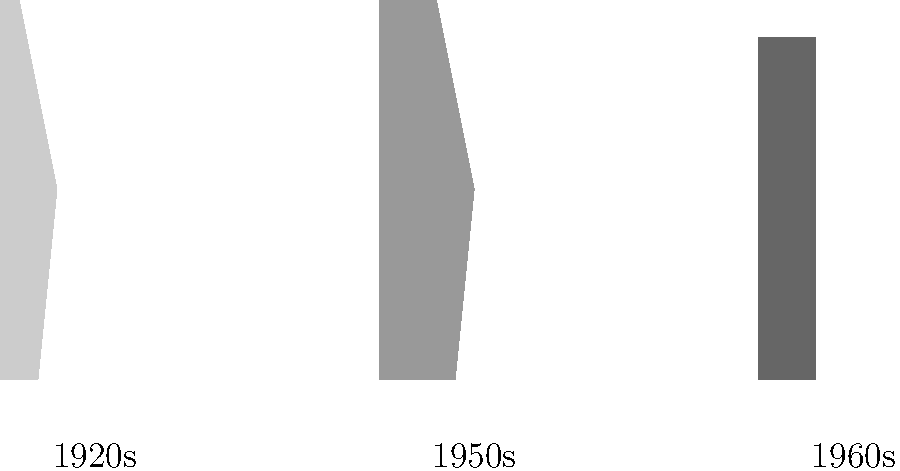Which era's silhouette would you say is the most 'waist-ing' opportunity for a cinched look? Explain your choice using fashion terminology and consider how this shape might influence modern 'dress-cussion' about body image. To answer this question, let's analyze each era's silhouette:

1. 1920s Flapper:
   - Straight, boyish figure
   - No defined waistline
   - Emphasis on loose, flowing fabrics

2. 1950s New Look:
   - Hourglass figure
   - Extremely defined waist
   - Full skirt creating a dramatic contrast

3. 1960s Mod:
   - Straight, boxy silhouette
   - Minimal waist definition
   - Focus on geometric shapes and shorter hemlines

The 1950s New Look silhouette, popularized by Christian Dior, is clearly the most 'waist-ing' opportunity for a cinched look. This era emphasized the importance of a tiny waist, often achieved through the use of corsets or girdles.

In terms of fashion terminology:
- The 1950s silhouette features a nipped-in waist, creating a dramatic contrast with the full bust and hips.
- This look often incorporated a corseted bodice to achieve the desired shape.
- The full skirt, often supported by petticoats, further accentuated the small waist.

Regarding modern 'dress-cussion' about body image:
- The extreme hourglass figure of the 1950s can be seen as promoting an unrealistic body ideal.
- This silhouette might contribute to discussions about body positivity and the pressure to achieve certain body shapes through fashion.
- It also raises questions about the balance between celebrating feminine curves and promoting potentially unhealthy body standards.
Answer: 1950s New Look 